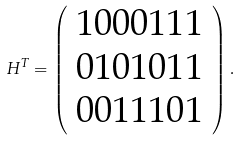Convert formula to latex. <formula><loc_0><loc_0><loc_500><loc_500>H ^ { T } = \left ( \begin{array} { c } 1 0 0 0 1 1 1 \\ 0 1 0 1 0 1 1 \\ 0 0 1 1 1 0 1 \end{array} \right ) .</formula> 